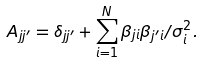<formula> <loc_0><loc_0><loc_500><loc_500>A _ { j j ^ { \prime } } = \delta _ { j j ^ { \prime } } + \sum _ { i = 1 } ^ { N } \beta _ { j i } \beta _ { j ^ { \prime } i } / \sigma _ { i } ^ { 2 } .</formula> 